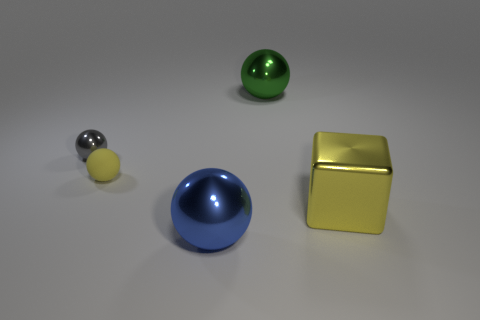What number of things are either tiny spheres in front of the small shiny object or cyan cubes?
Your response must be concise. 1. Are there any other green metallic things that have the same shape as the big green metallic object?
Provide a short and direct response. No. What is the shape of the shiny thing right of the large thing behind the yellow cube?
Your answer should be very brief. Cube. What number of blocks are yellow things or large yellow objects?
Your answer should be very brief. 1. There is a small object that is the same color as the cube; what material is it?
Your answer should be very brief. Rubber. There is a object that is in front of the yellow block; is its shape the same as the small thing left of the tiny matte sphere?
Make the answer very short. Yes. What color is the object that is both right of the big blue metal sphere and behind the large yellow block?
Keep it short and to the point. Green. There is a large block; is its color the same as the large metallic thing in front of the metal block?
Offer a very short reply. No. What is the size of the metal ball that is behind the large blue shiny thing and on the right side of the gray metallic ball?
Provide a short and direct response. Large. What number of other things are there of the same color as the metal block?
Provide a short and direct response. 1. 